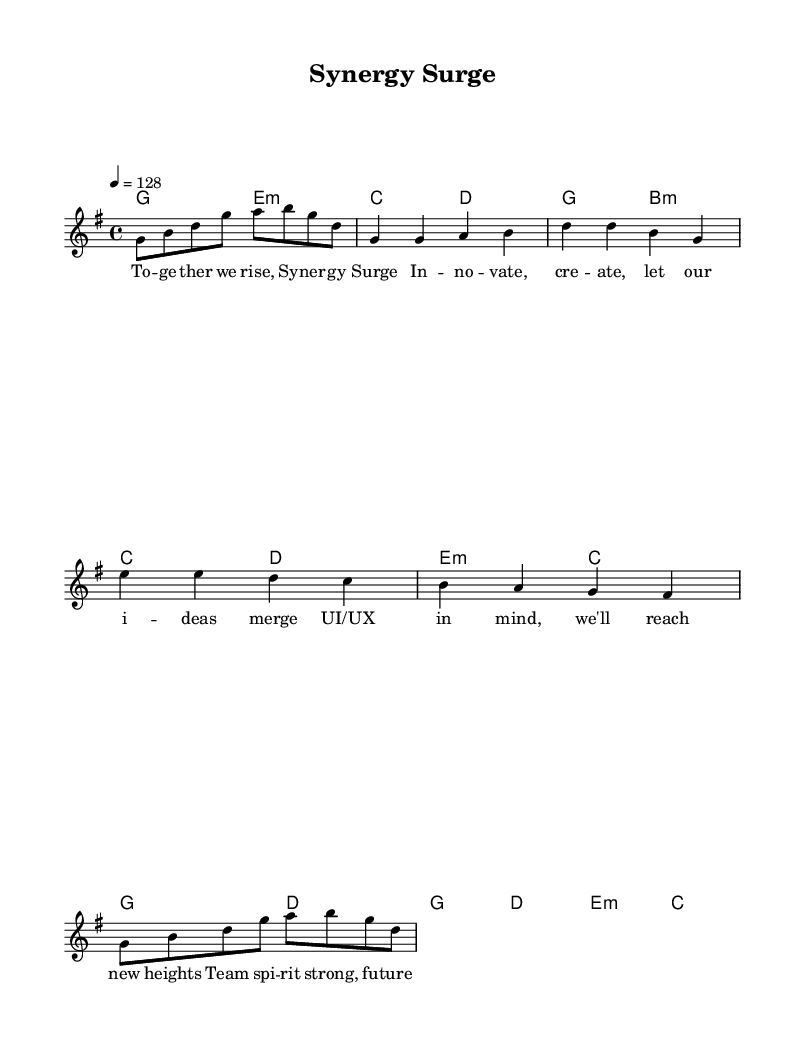What is the key signature of this music? The key signature is G major, which has one sharp (F#). This can be identified in the beginning of the score where the key signature is visually indicated.
Answer: G major What is the time signature of this music? The time signature is 4/4, which means there are four beats in a measure and the quarter note gets one beat. This is indicated at the beginning of the sheet music next to the key signature.
Answer: 4/4 What is the tempo of this piece? The tempo is 128 beats per minute. This is indicated above the score with the marking "4 = 128," specifying the speed of the music.
Answer: 128 How many measures are there in the verse section? There are four measures in the verse section, evident from counting the measures indicated by the bar lines in the melody part of the score.
Answer: 4 What is the predominant harmony used in the chorus? The predominant harmony in the chorus is G major. The chords listed in the harmonies section show that G major is the starting chord of the chorus, defining its tonal center.
Answer: G major What is the lyrical theme of this piece? The lyrical theme focuses on teamwork and innovation, as suggested by the words "Together we rise" and "Team spirit strong" in the lyrics associated with the melody.
Answer: Teamwork How does the pre-chorus differ from the verse in terms of melody? The pre-chorus melody uses a wider pitch range, moving higher, while the verse stays lower and simpler. This can be deduced from observing the notes in the melody sections of both parts, where the pre-chorus introduces higher notes.
Answer: Wider pitch range 